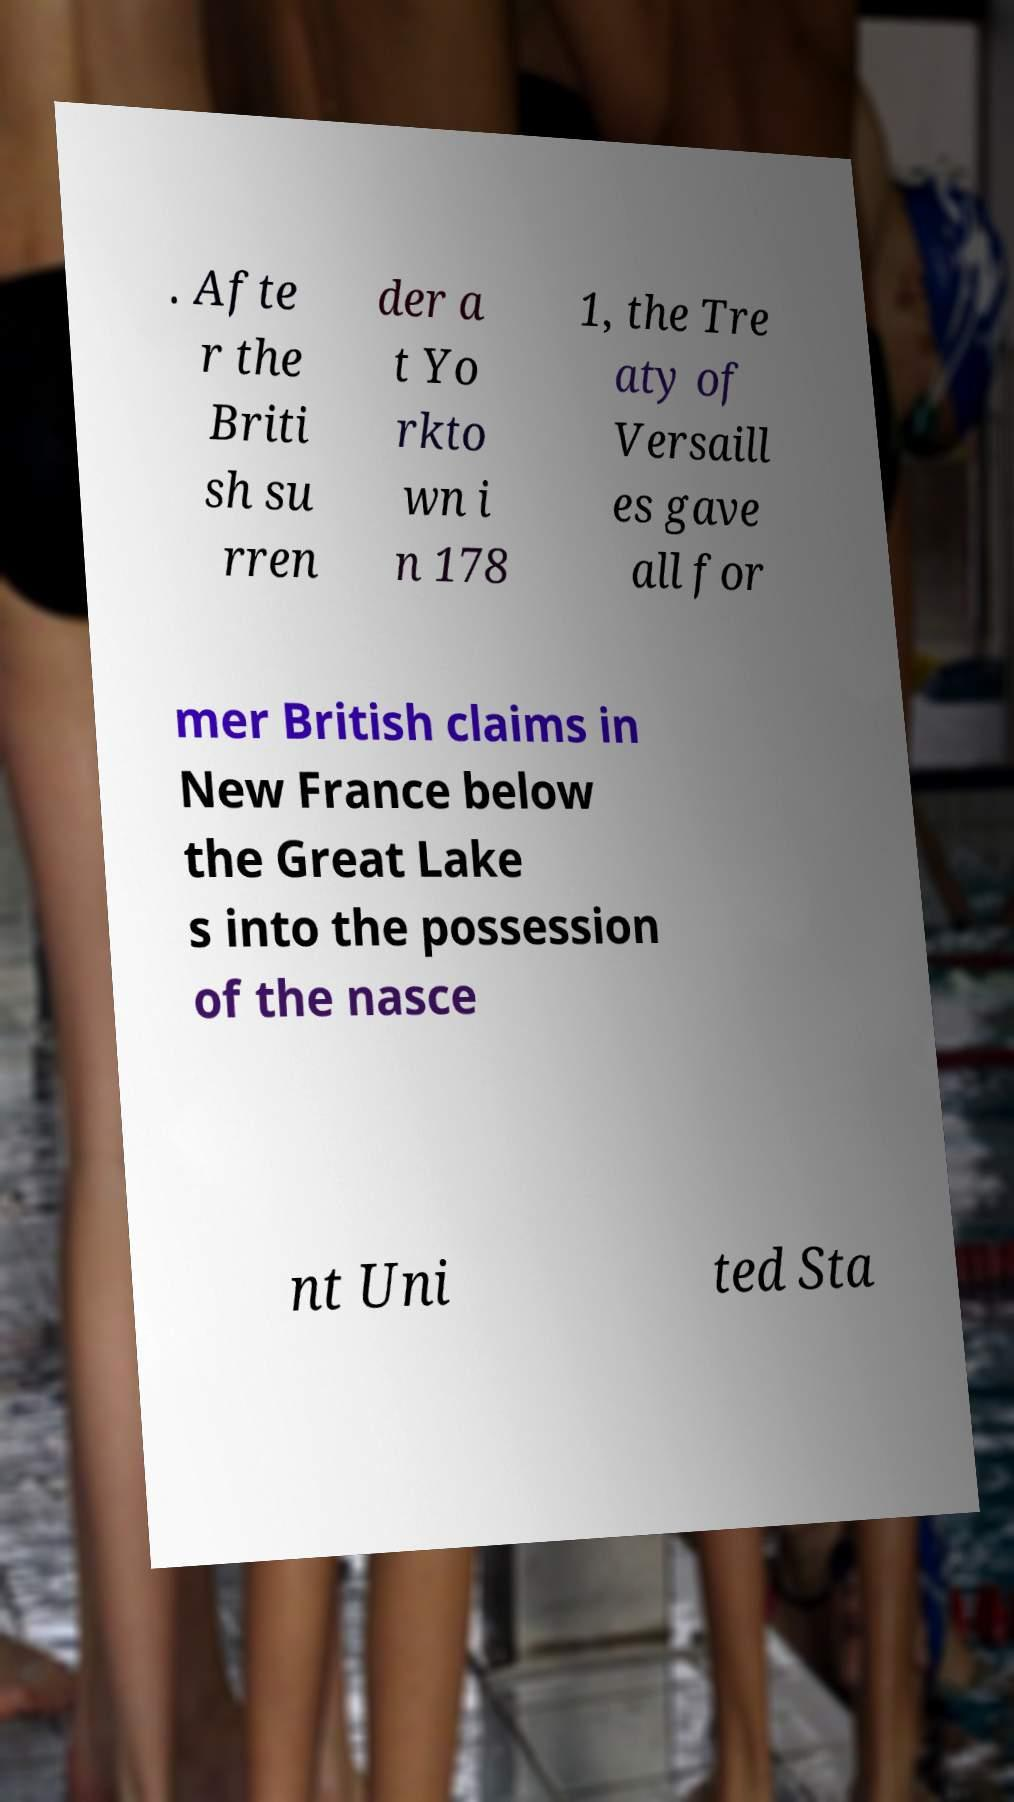What messages or text are displayed in this image? I need them in a readable, typed format. . Afte r the Briti sh su rren der a t Yo rkto wn i n 178 1, the Tre aty of Versaill es gave all for mer British claims in New France below the Great Lake s into the possession of the nasce nt Uni ted Sta 